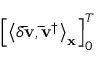Convert formula to latex. <formula><loc_0><loc_0><loc_500><loc_500>\left [ { { { \left \langle { \delta { \bar { v } } , { { { \bar { v } } } ^ { \dag } } } \right \rangle } _ { x } } } \right ] _ { 0 } ^ { T }</formula> 